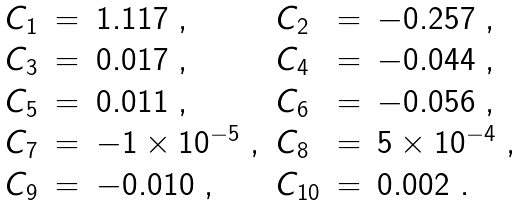Convert formula to latex. <formula><loc_0><loc_0><loc_500><loc_500>\begin{array} { l l l l l l } C _ { 1 } & = & 1 . 1 1 7 \ , & C _ { 2 } & = & - 0 . 2 5 7 \ , \\ C _ { 3 } & = & 0 . 0 1 7 \ , & C _ { 4 } & = & - 0 . 0 4 4 \ , \\ C _ { 5 } & = & 0 . 0 1 1 \ , & C _ { 6 } & = & - 0 . 0 5 6 \ , \\ C _ { 7 } & = & - 1 \times 1 0 ^ { - 5 } \ , & C _ { 8 } & = & 5 \times 1 0 ^ { - 4 } \ , \\ C _ { 9 } & = & - 0 . 0 1 0 \ , & C _ { 1 0 } & = & 0 . 0 0 2 \ . \\ \end{array}</formula> 